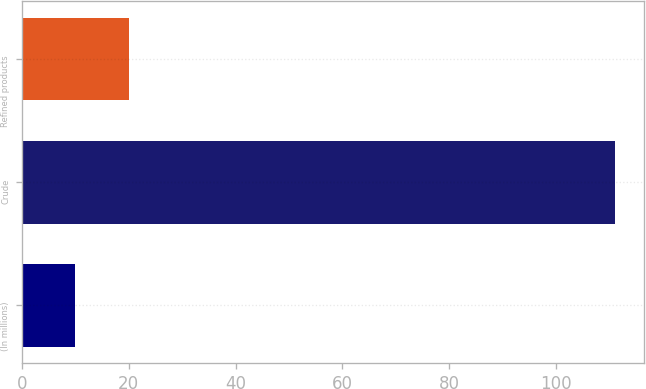<chart> <loc_0><loc_0><loc_500><loc_500><bar_chart><fcel>(In millions)<fcel>Crude<fcel>Refined products<nl><fcel>10<fcel>111<fcel>20.1<nl></chart> 